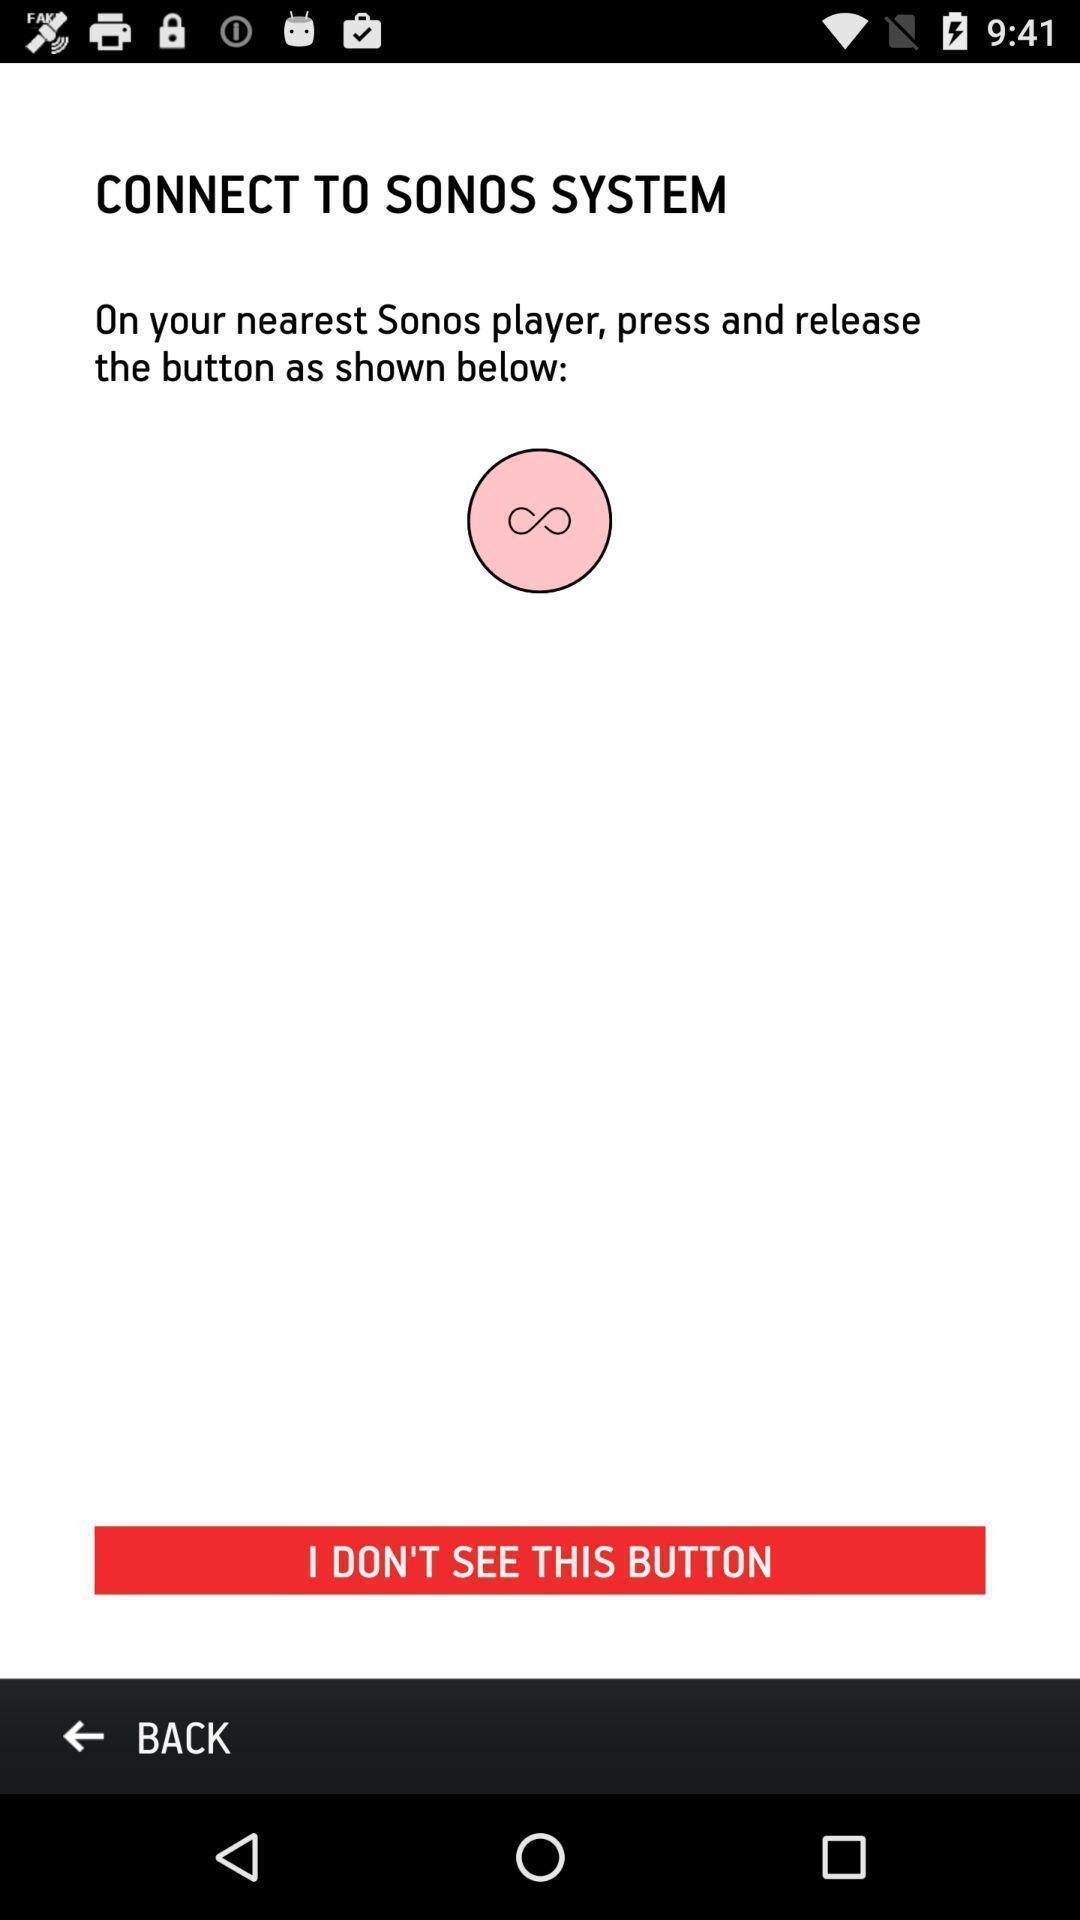Provide a detailed account of this screenshot. Page requesting to connect to sonos system. 